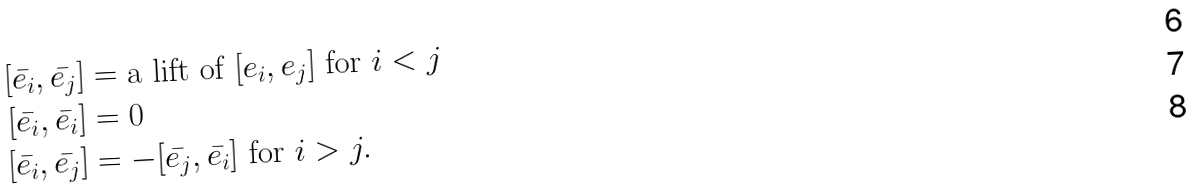Convert formula to latex. <formula><loc_0><loc_0><loc_500><loc_500>[ \bar { e _ { i } } , \bar { e _ { j } } ] & = \text {a lift of } [ e _ { i } , e _ { j } ] \text { for } i < j \\ [ \bar { e _ { i } } , \bar { e _ { i } } ] & = 0 \\ [ \bar { e _ { i } } , \bar { e _ { j } } ] & = - [ \bar { e _ { j } } , \bar { e _ { i } } ] \text { for } i > j .</formula> 